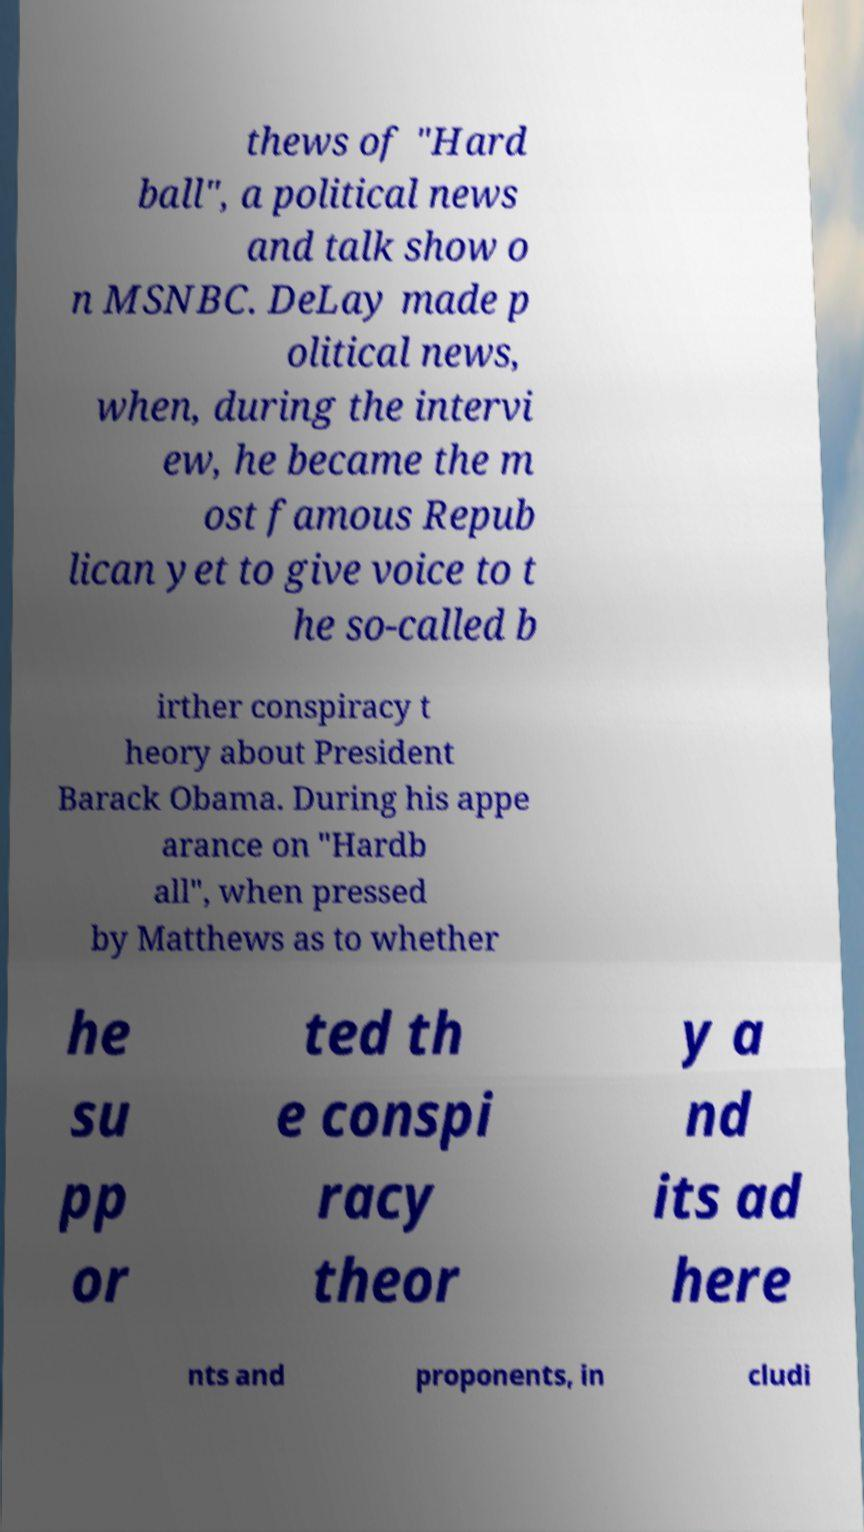For documentation purposes, I need the text within this image transcribed. Could you provide that? thews of "Hard ball", a political news and talk show o n MSNBC. DeLay made p olitical news, when, during the intervi ew, he became the m ost famous Repub lican yet to give voice to t he so-called b irther conspiracy t heory about President Barack Obama. During his appe arance on "Hardb all", when pressed by Matthews as to whether he su pp or ted th e conspi racy theor y a nd its ad here nts and proponents, in cludi 